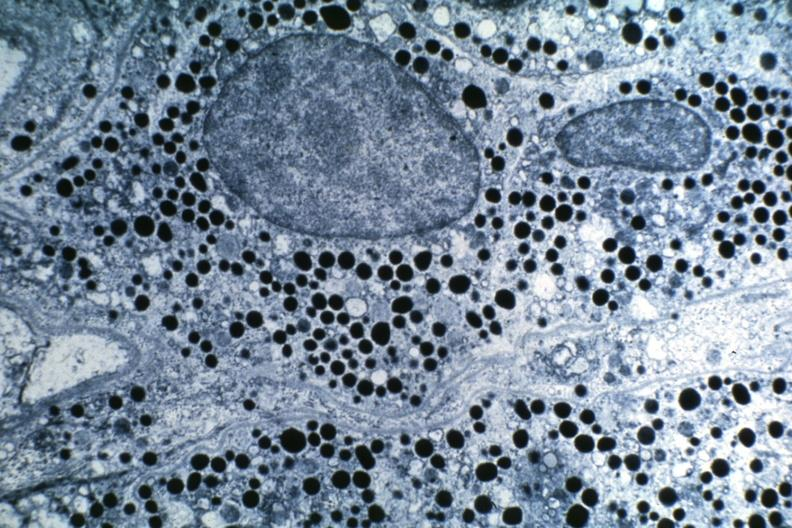what is present?
Answer the question using a single word or phrase. Pituitary 